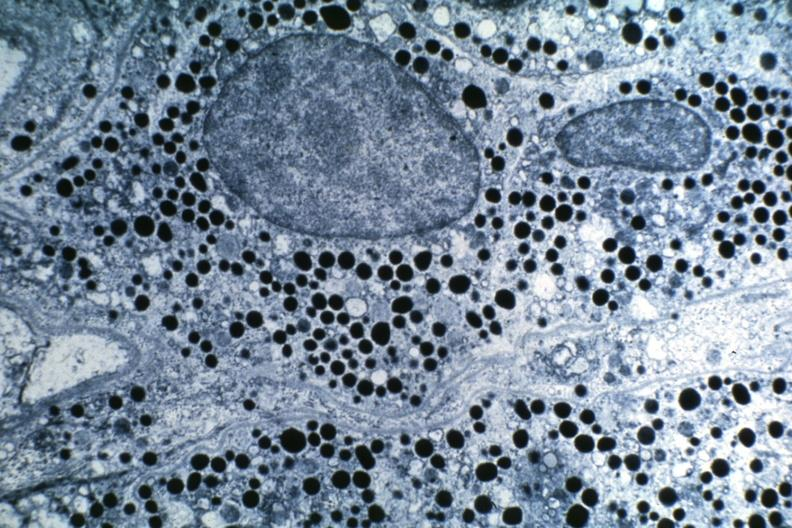what is present?
Answer the question using a single word or phrase. Pituitary 